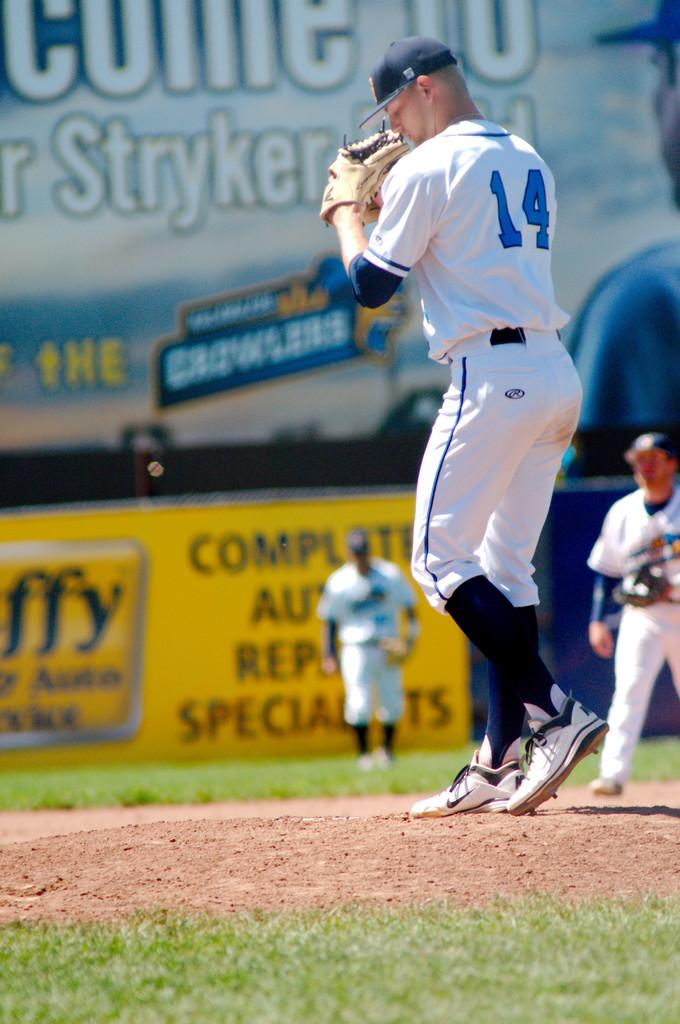<image>
Write a terse but informative summary of the picture. The player has a jersey that has the number 14 on it. 